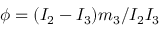<formula> <loc_0><loc_0><loc_500><loc_500>\phi = ( I _ { 2 } - I _ { 3 } ) m _ { 3 } / I _ { 2 } I _ { 3 }</formula> 